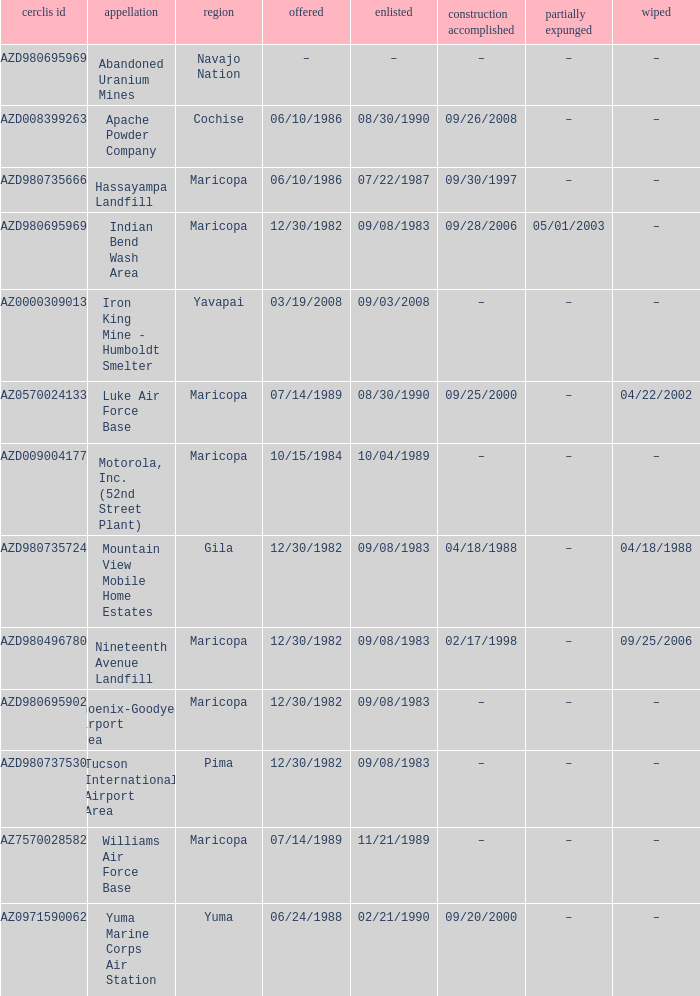When was the site partially deleted when the cerclis id is az7570028582? –. 